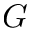<formula> <loc_0><loc_0><loc_500><loc_500>G</formula> 